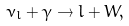Convert formula to latex. <formula><loc_0><loc_0><loc_500><loc_500>\nu _ { l } + \gamma \rightarrow l + W ,</formula> 